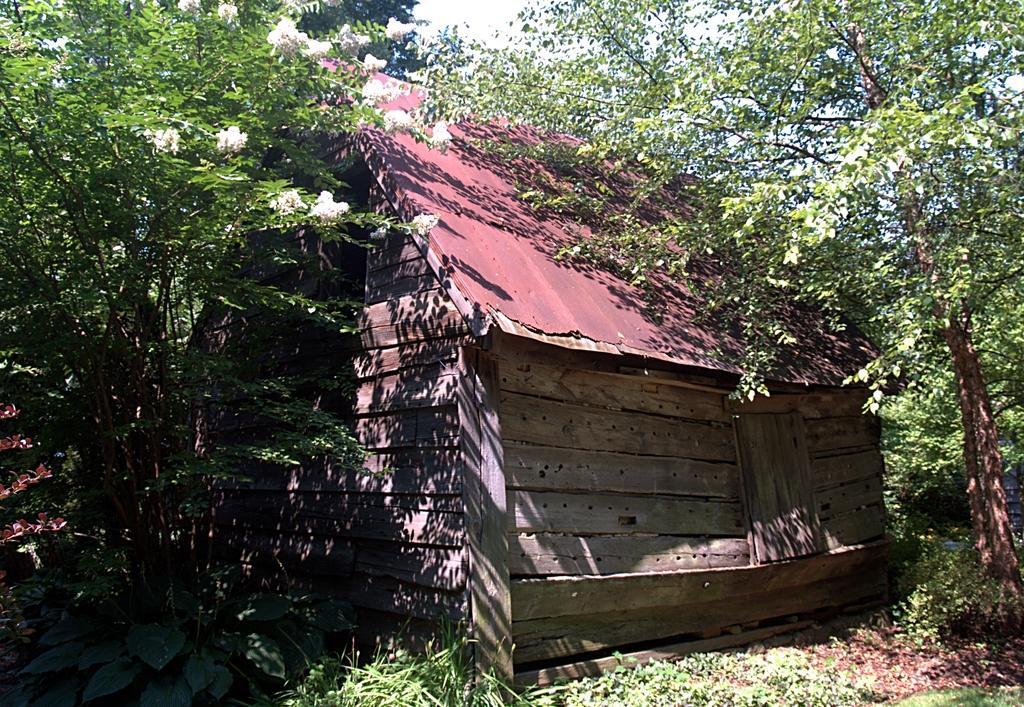Please provide a concise description of this image. In the image we can see some trees and house. At the top of the image we can see the sky. 